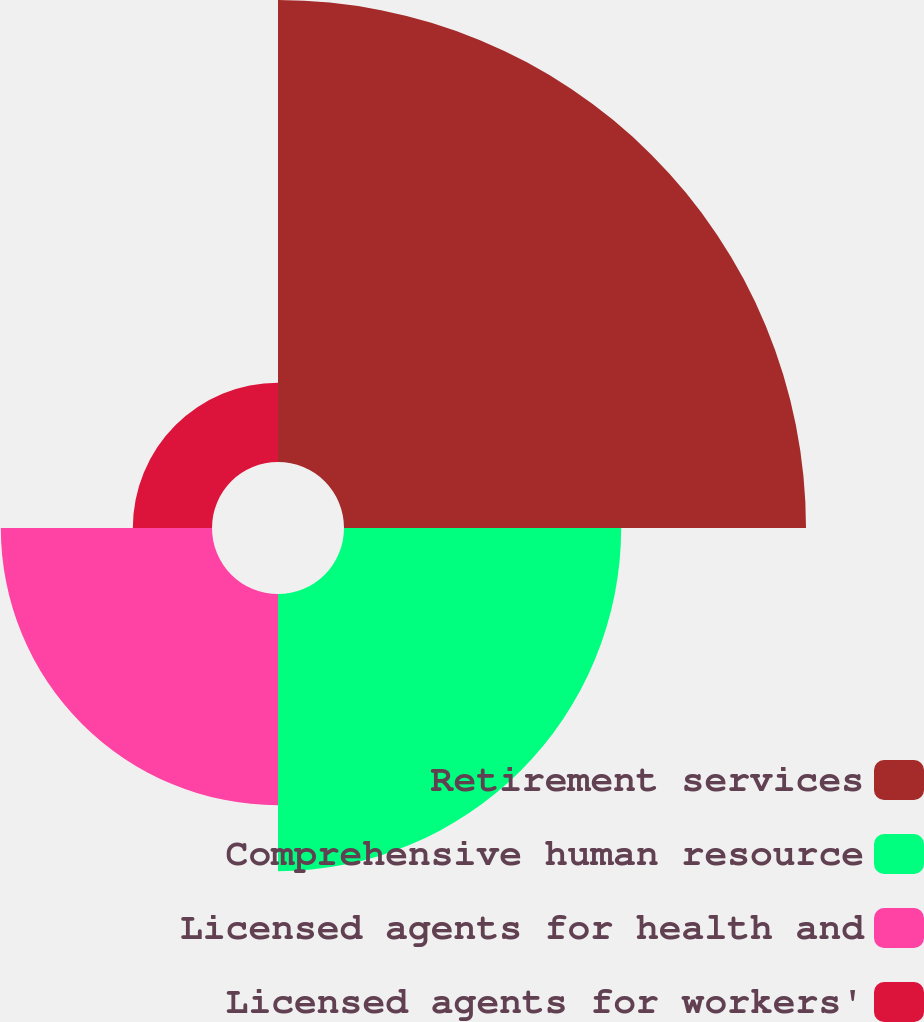<chart> <loc_0><loc_0><loc_500><loc_500><pie_chart><fcel>Retirement services<fcel>Comprehensive human resource<fcel>Licensed agents for health and<fcel>Licensed agents for workers'<nl><fcel>44.87%<fcel>26.92%<fcel>20.51%<fcel>7.69%<nl></chart> 